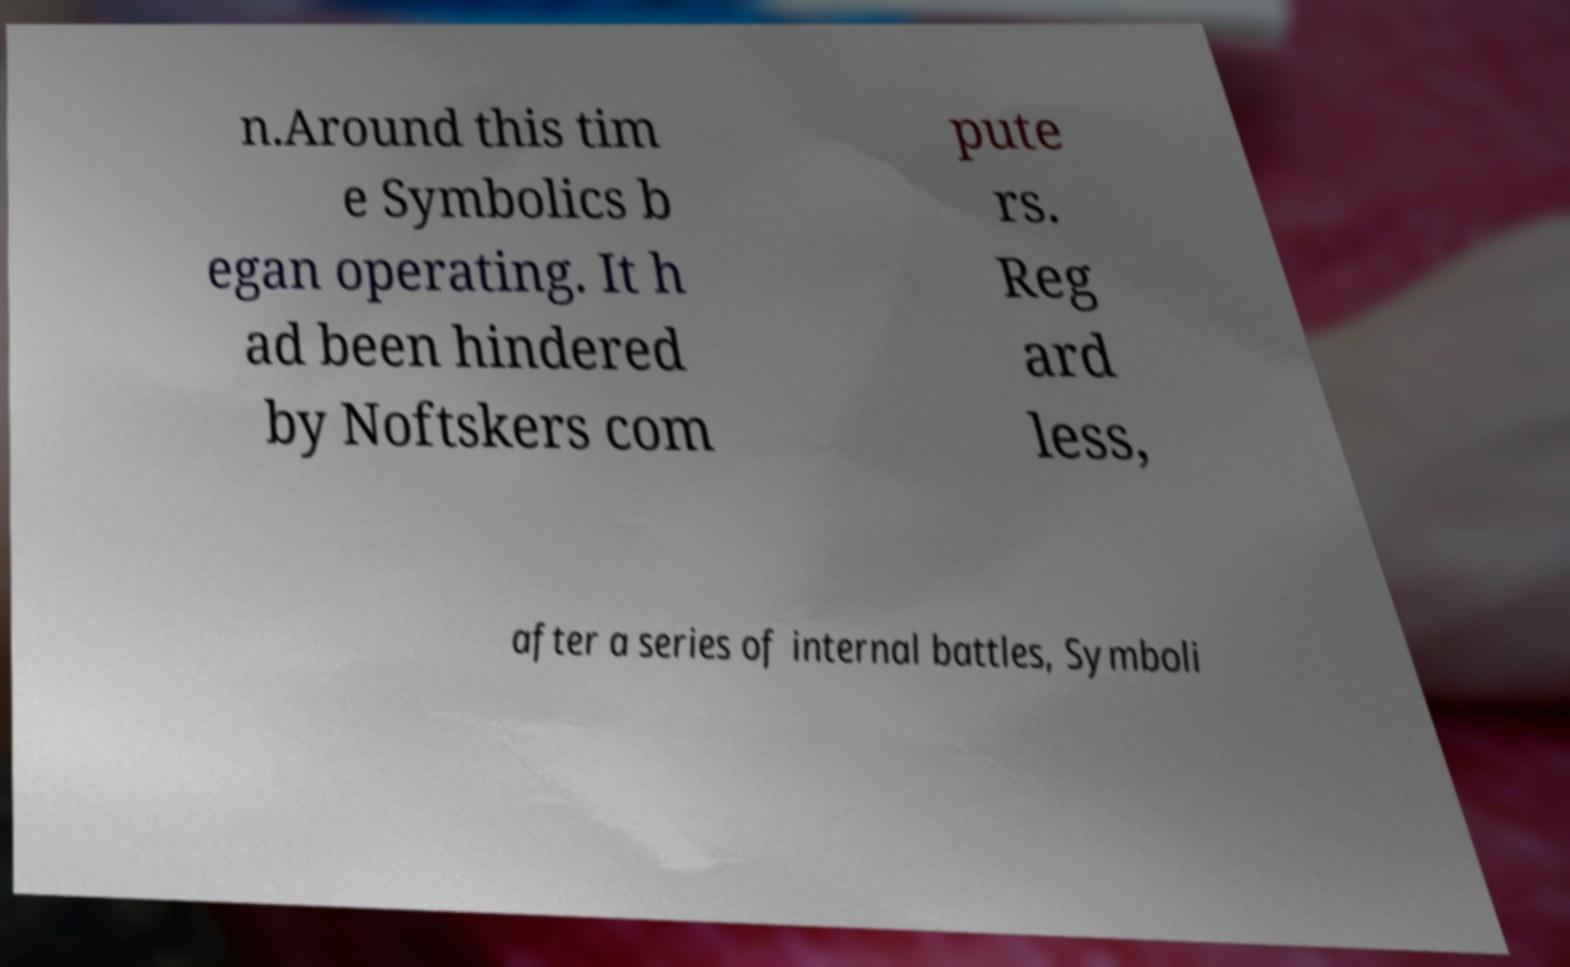Can you accurately transcribe the text from the provided image for me? n.Around this tim e Symbolics b egan operating. It h ad been hindered by Noftskers com pute rs. Reg ard less, after a series of internal battles, Symboli 